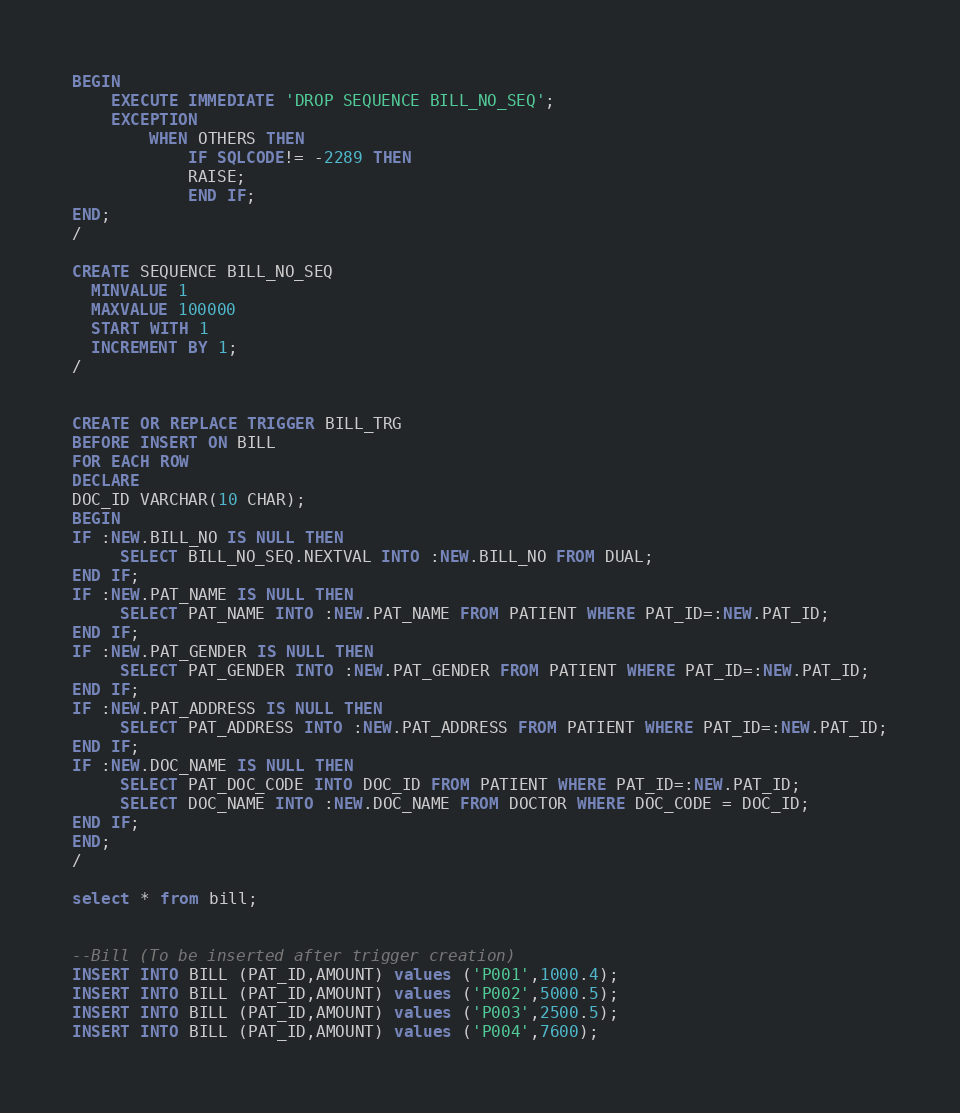<code> <loc_0><loc_0><loc_500><loc_500><_SQL_>BEGIN
    EXECUTE IMMEDIATE 'DROP SEQUENCE BILL_NO_SEQ';
    EXCEPTION
        WHEN OTHERS THEN
            IF SQLCODE!= -2289 THEN
            RAISE;
            END IF;
END;
/

CREATE SEQUENCE BILL_NO_SEQ
  MINVALUE 1
  MAXVALUE 100000
  START WITH 1
  INCREMENT BY 1;
/ 


CREATE OR REPLACE TRIGGER BILL_TRG
BEFORE INSERT ON BILL
FOR EACH ROW
DECLARE
DOC_ID VARCHAR(10 CHAR);
BEGIN
IF :NEW.BILL_NO IS NULL THEN
     SELECT BILL_NO_SEQ.NEXTVAL INTO :NEW.BILL_NO FROM DUAL;
END IF;
IF :NEW.PAT_NAME IS NULL THEN
     SELECT PAT_NAME INTO :NEW.PAT_NAME FROM PATIENT WHERE PAT_ID=:NEW.PAT_ID;
END IF;
IF :NEW.PAT_GENDER IS NULL THEN
     SELECT PAT_GENDER INTO :NEW.PAT_GENDER FROM PATIENT WHERE PAT_ID=:NEW.PAT_ID;
END IF;
IF :NEW.PAT_ADDRESS IS NULL THEN
     SELECT PAT_ADDRESS INTO :NEW.PAT_ADDRESS FROM PATIENT WHERE PAT_ID=:NEW.PAT_ID;
END IF;
IF :NEW.DOC_NAME IS NULL THEN
     SELECT PAT_DOC_CODE INTO DOC_ID FROM PATIENT WHERE PAT_ID=:NEW.PAT_ID;
	 SELECT DOC_NAME INTO :NEW.DOC_NAME FROM DOCTOR WHERE DOC_CODE = DOC_ID;
END IF;
END;
/

select * from bill;


--Bill (To be inserted after trigger creation)
INSERT INTO BILL (PAT_ID,AMOUNT) values ('P001',1000.4);
INSERT INTO BILL (PAT_ID,AMOUNT) values ('P002',5000.5);
INSERT INTO BILL (PAT_ID,AMOUNT) values ('P003',2500.5);
INSERT INTO BILL (PAT_ID,AMOUNT) values ('P004',7600);</code> 